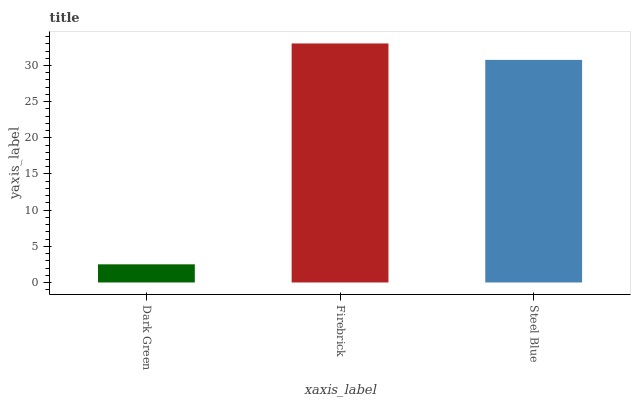Is Dark Green the minimum?
Answer yes or no. Yes. Is Firebrick the maximum?
Answer yes or no. Yes. Is Steel Blue the minimum?
Answer yes or no. No. Is Steel Blue the maximum?
Answer yes or no. No. Is Firebrick greater than Steel Blue?
Answer yes or no. Yes. Is Steel Blue less than Firebrick?
Answer yes or no. Yes. Is Steel Blue greater than Firebrick?
Answer yes or no. No. Is Firebrick less than Steel Blue?
Answer yes or no. No. Is Steel Blue the high median?
Answer yes or no. Yes. Is Steel Blue the low median?
Answer yes or no. Yes. Is Dark Green the high median?
Answer yes or no. No. Is Dark Green the low median?
Answer yes or no. No. 